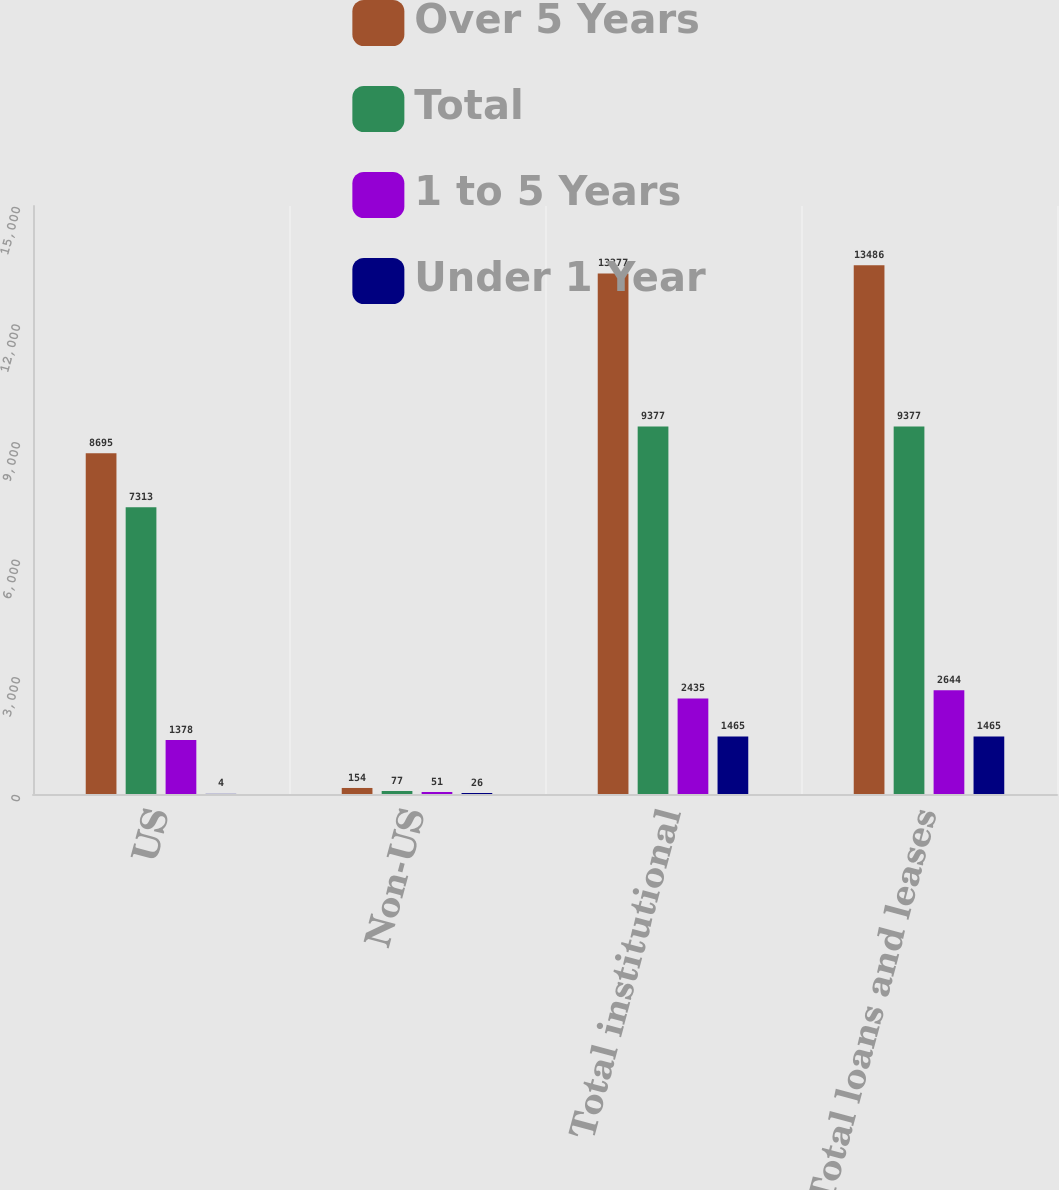Convert chart. <chart><loc_0><loc_0><loc_500><loc_500><stacked_bar_chart><ecel><fcel>US<fcel>Non-US<fcel>Total institutional<fcel>Total loans and leases<nl><fcel>Over 5 Years<fcel>8695<fcel>154<fcel>13277<fcel>13486<nl><fcel>Total<fcel>7313<fcel>77<fcel>9377<fcel>9377<nl><fcel>1 to 5 Years<fcel>1378<fcel>51<fcel>2435<fcel>2644<nl><fcel>Under 1 Year<fcel>4<fcel>26<fcel>1465<fcel>1465<nl></chart> 